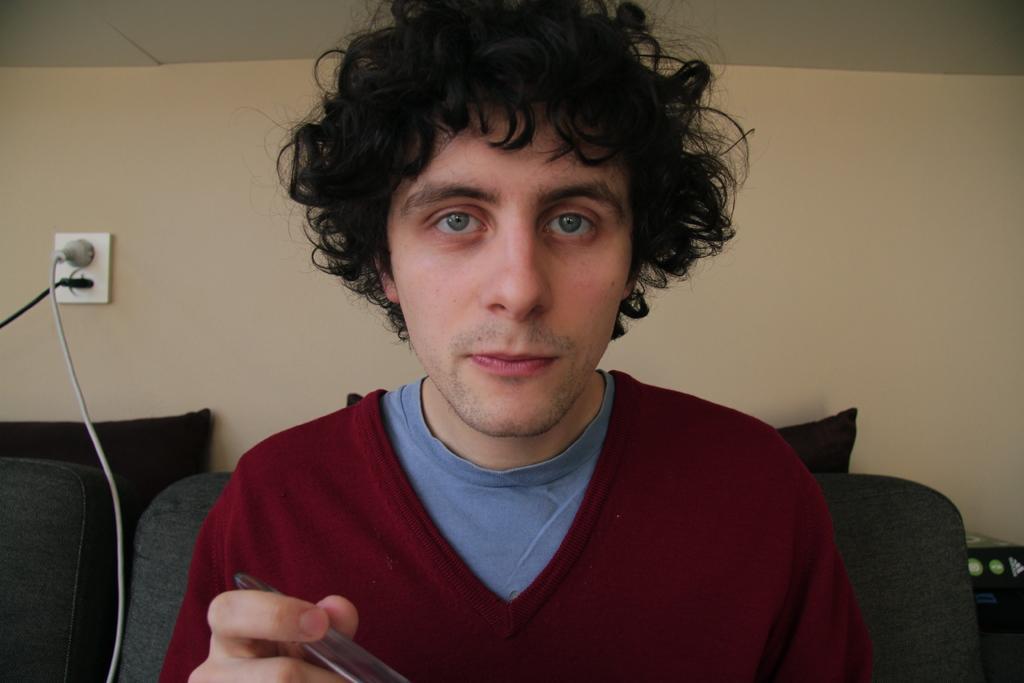Can you describe this image briefly? In this image I can see a person holding something. He is wearing maroon and blue color dress. Back I can see a couch,pillows and cream wall. 